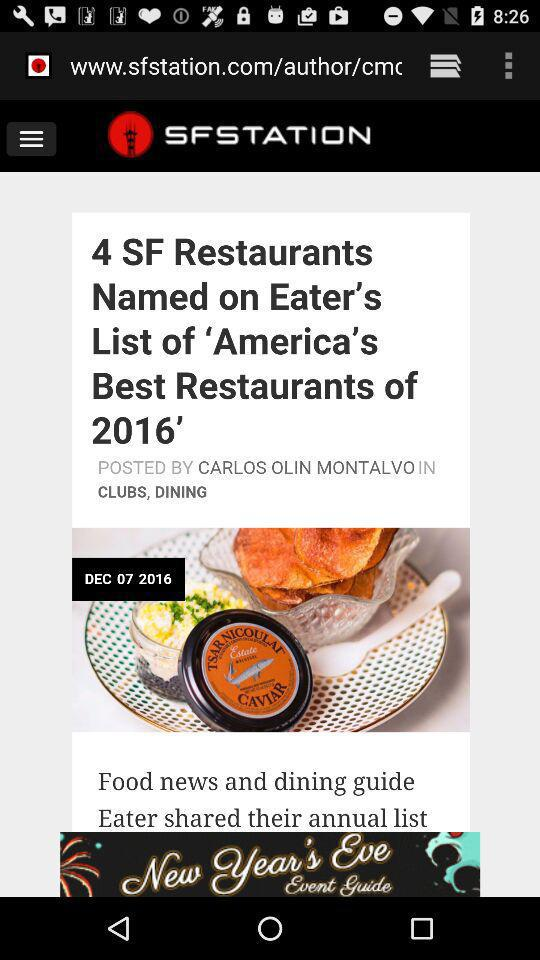What is the website name? The website name is "www.sfstation.com/author/cm". 